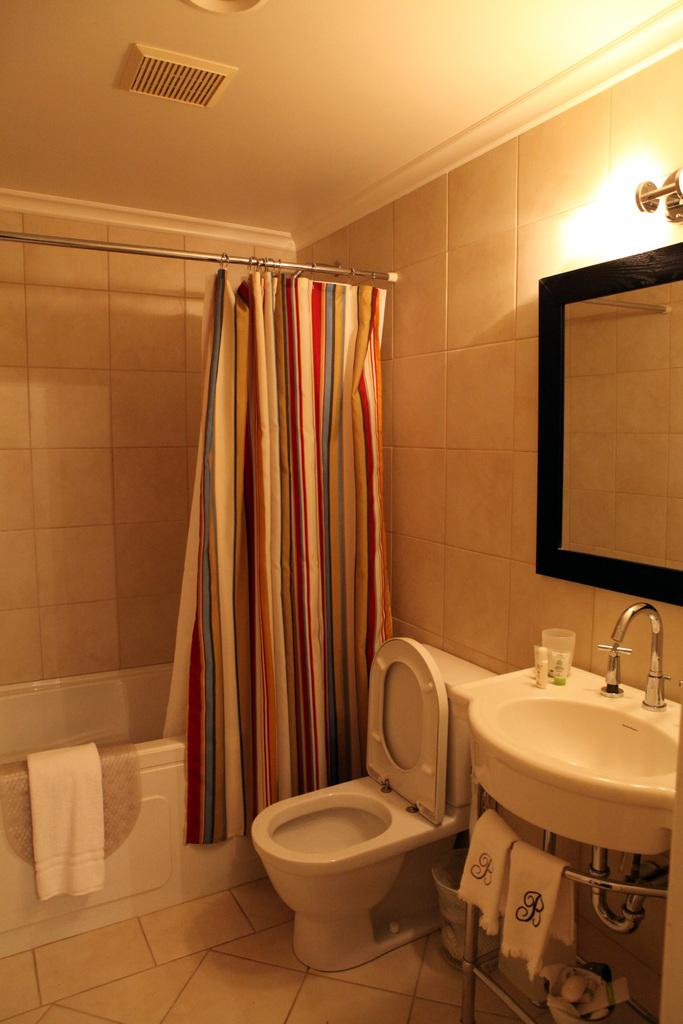What type of room is depicted in the image? The image shows the inner view of a washroom. What can be seen hanging in the washroom? There is a shower curtain in the washroom. What is present in the washroom for bathing purposes? There is a bathtub in the washroom. What can be used for drying oneself after bathing? Towels are present in the washroom. What is the purpose of the toilet seat in the washroom? The toilet seat is for sitting while using the toilet. What is present in the washroom for washing hands? There is a sink in the washroom, and a tap is present on the sink. What can be used for personal grooming in the washroom? There is a mirror in the washroom. How is the washroom illuminated? An electric light is visible in the washroom. What type of stem can be seen growing from the sink in the image? There is no stem growing from the sink in the image. What channel is playing on the television in the washroom? There is no television present in the washroom. How many light bulbs are visible in the image? There is no mention of light bulbs in the image; only an electric light is mentioned. 